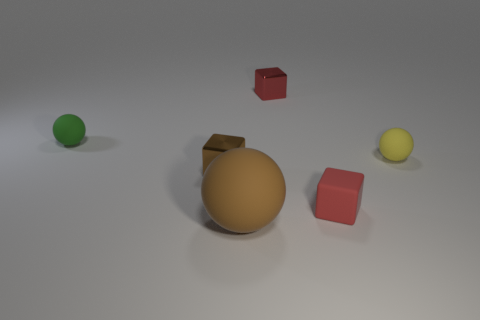Add 1 small matte cubes. How many objects exist? 7 Subtract all big red metal cylinders. Subtract all tiny red matte cubes. How many objects are left? 5 Add 2 small brown objects. How many small brown objects are left? 3 Add 5 big purple metallic things. How many big purple metallic things exist? 5 Subtract 1 green spheres. How many objects are left? 5 